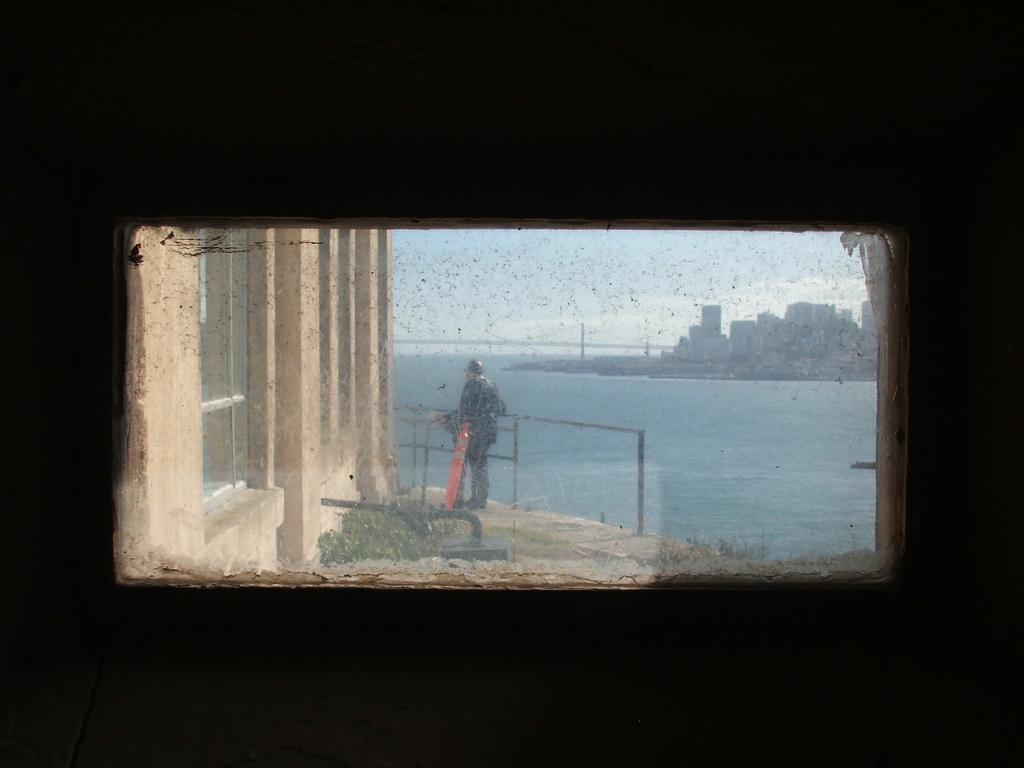Could you give a brief overview of what you see in this image? In this image we can see the wall with a window, through the window we can see some buildings, water, plants and a person, in the background, we can see the sky with clouds. 